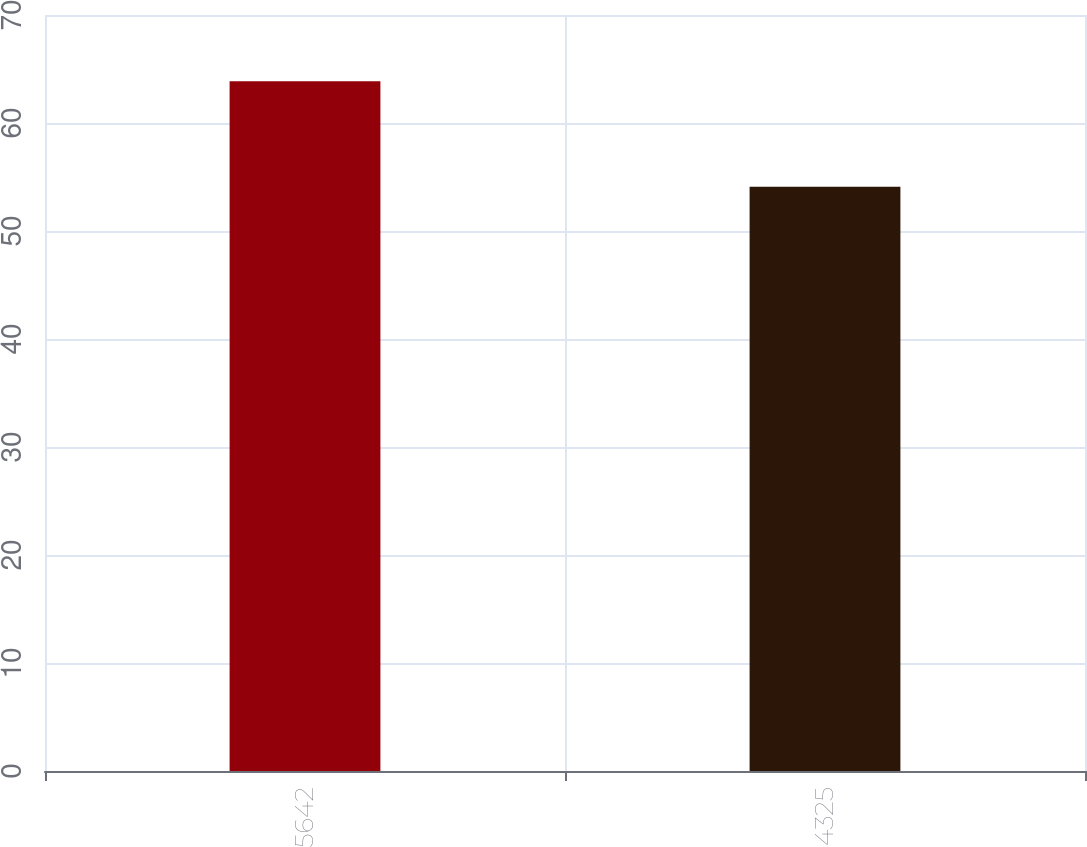Convert chart. <chart><loc_0><loc_0><loc_500><loc_500><bar_chart><fcel>5642<fcel>4325<nl><fcel>63.87<fcel>54.1<nl></chart> 